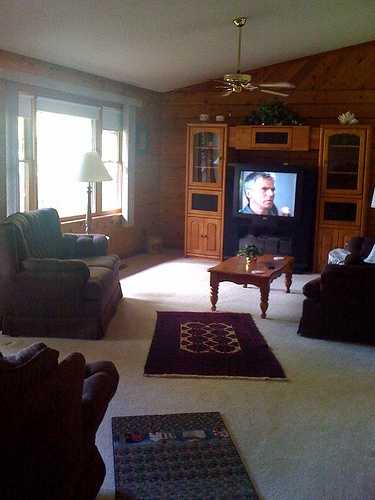Describe the objects in this image and their specific colors. I can see couch in gray and black tones, couch in gray, black, and purple tones, tv in gray, black, lavender, and lightblue tones, couch in gray and black tones, and dining table in gray, maroon, black, and brown tones in this image. 